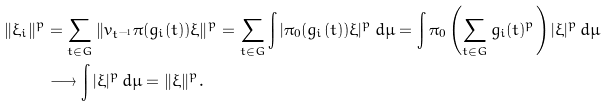<formula> <loc_0><loc_0><loc_500><loc_500>\| \xi _ { i } \| ^ { p } & = \sum _ { t \in G } \| v _ { t ^ { - 1 } } \pi ( g _ { i } ( t ) ) \xi \| ^ { p } = \sum _ { t \in G } \int | \pi _ { 0 } ( g _ { i } ( t ) ) \xi | ^ { p } \, d \mu = \int \pi _ { 0 } \left ( \sum _ { t \in G } g _ { i } ( t ) ^ { p } \right ) | \xi | ^ { p } \, d \mu \\ & \longrightarrow \int | \xi | ^ { p } \, d \mu = \| \xi \| ^ { p } .</formula> 